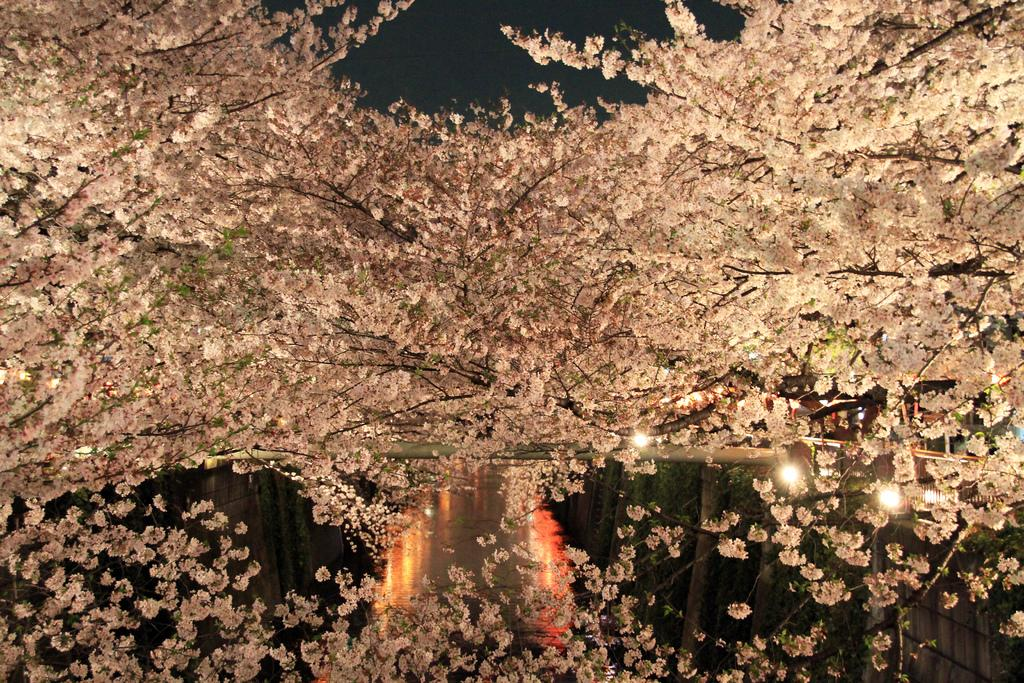What type of vegetation can be seen in the image? There are many trees in the image. What else is visible in the image besides the trees? There are lights visible in the image. What is the color of the background in the image? The background of the image is black. How many cacti are present in the image? There are no cacti present in the image; it features many trees and lights. 